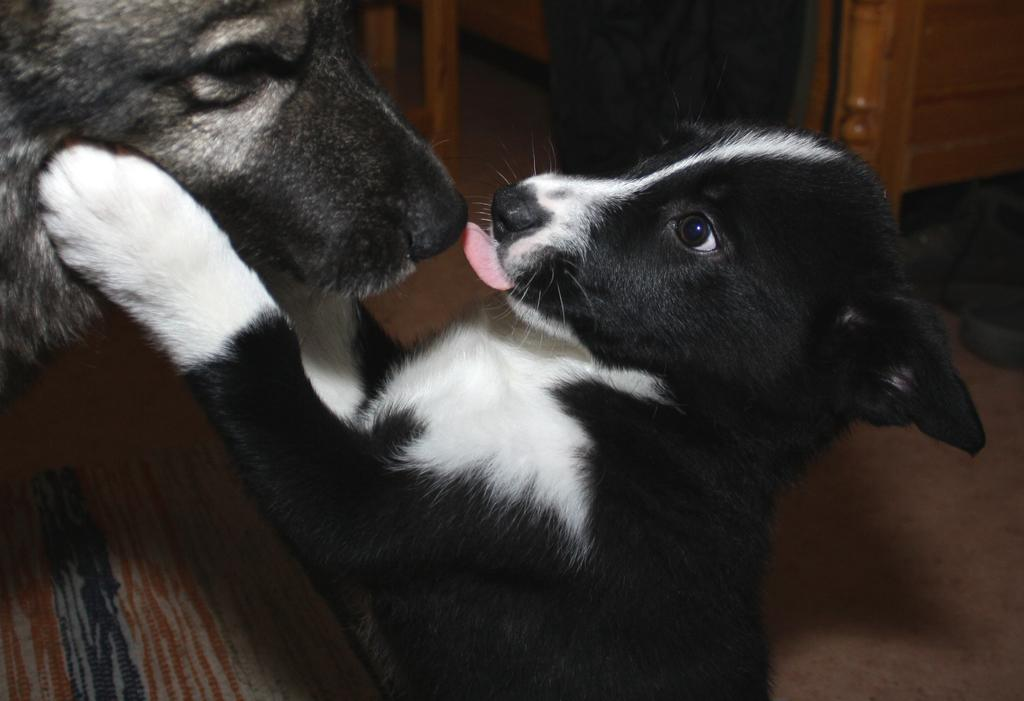How many dogs are present in the image? There are two dogs in the image. Can you describe anything else visible in the image besides the dogs? Yes, there are legs of a person visible behind the dogs, and there are wooden structures in the image. What type of tree can be seen in the garden in the image? There is no garden or tree present in the image; it features two dogs and wooden structures. 